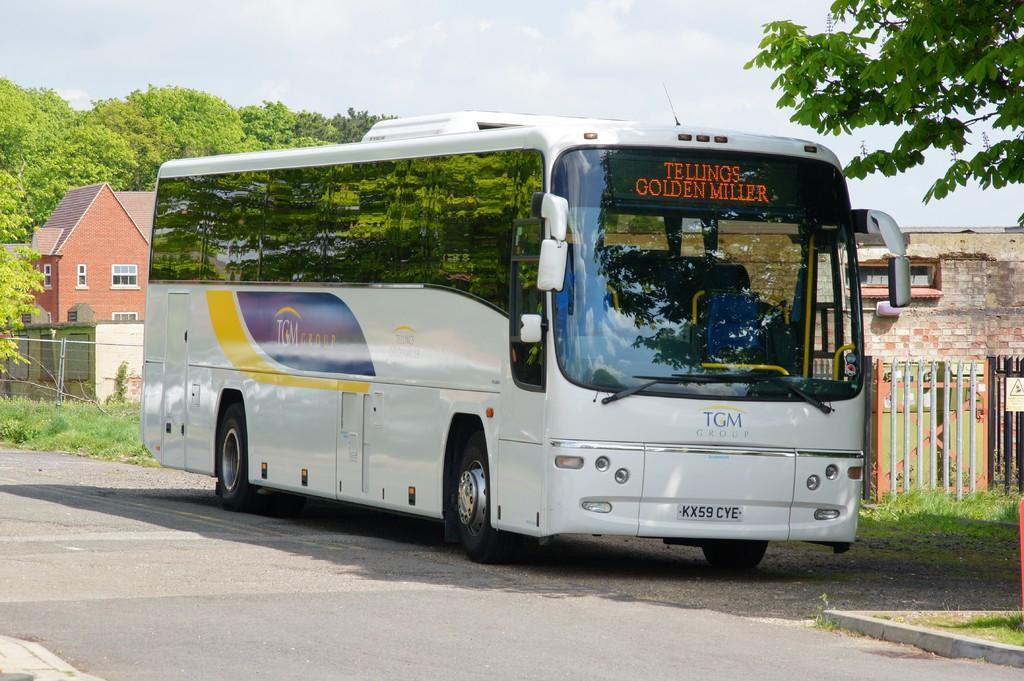Please provide a concise description of this image. In this image I can see a white bus on a road, there are fences, houses and trees at the back. There is sky at the top. 